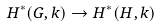Convert formula to latex. <formula><loc_0><loc_0><loc_500><loc_500>H ^ { * } ( G , k ) \rightarrow H ^ { * } ( H , k )</formula> 